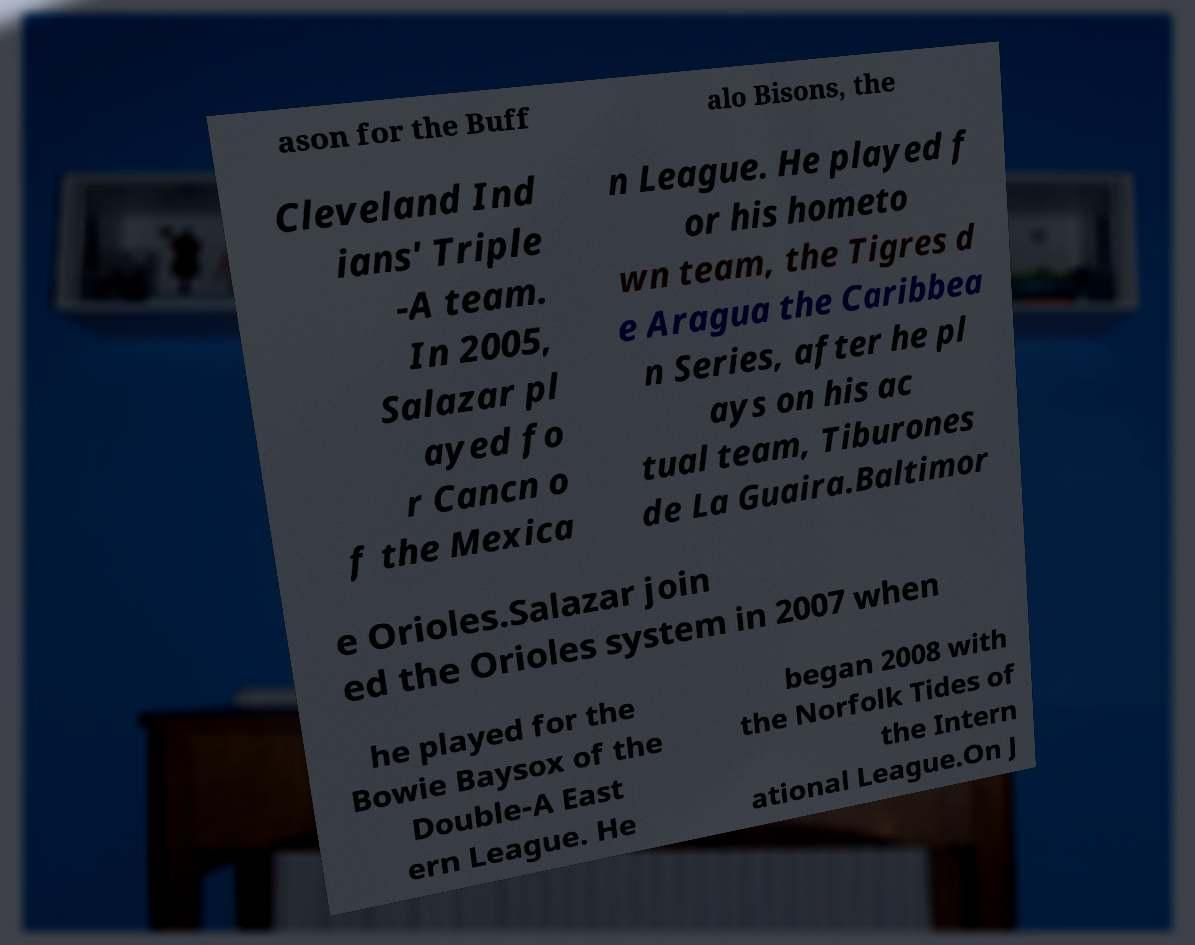Could you extract and type out the text from this image? ason for the Buff alo Bisons, the Cleveland Ind ians' Triple -A team. In 2005, Salazar pl ayed fo r Cancn o f the Mexica n League. He played f or his hometo wn team, the Tigres d e Aragua the Caribbea n Series, after he pl ays on his ac tual team, Tiburones de La Guaira.Baltimor e Orioles.Salazar join ed the Orioles system in 2007 when he played for the Bowie Baysox of the Double-A East ern League. He began 2008 with the Norfolk Tides of the Intern ational League.On J 